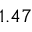Convert formula to latex. <formula><loc_0><loc_0><loc_500><loc_500>1 . 4 7</formula> 